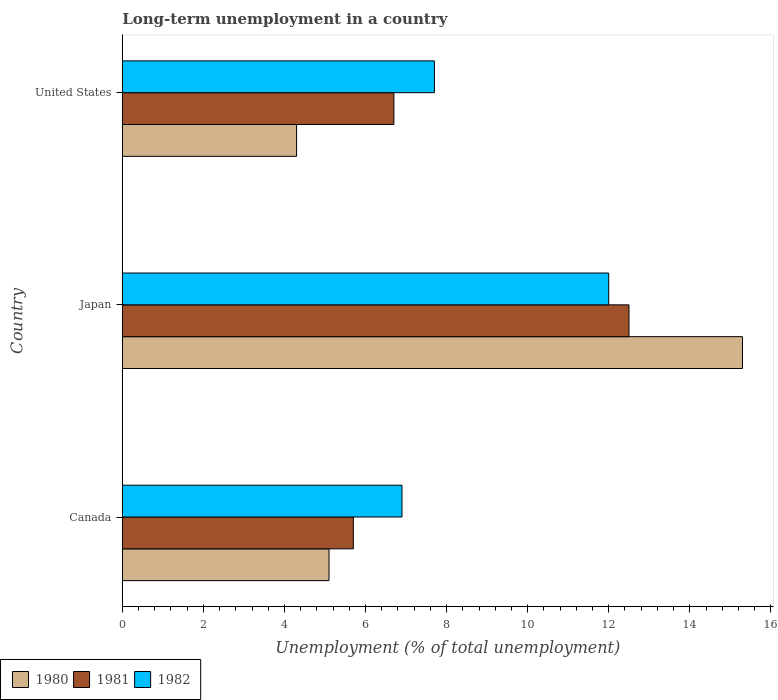How many different coloured bars are there?
Provide a succinct answer. 3. How many groups of bars are there?
Offer a terse response. 3. Are the number of bars per tick equal to the number of legend labels?
Your answer should be compact. Yes. How many bars are there on the 3rd tick from the top?
Your response must be concise. 3. What is the label of the 2nd group of bars from the top?
Your response must be concise. Japan. In how many cases, is the number of bars for a given country not equal to the number of legend labels?
Your answer should be very brief. 0. What is the percentage of long-term unemployed population in 1980 in Japan?
Give a very brief answer. 15.3. Across all countries, what is the maximum percentage of long-term unemployed population in 1982?
Your response must be concise. 12. Across all countries, what is the minimum percentage of long-term unemployed population in 1982?
Offer a very short reply. 6.9. In which country was the percentage of long-term unemployed population in 1981 maximum?
Your response must be concise. Japan. What is the total percentage of long-term unemployed population in 1982 in the graph?
Make the answer very short. 26.6. What is the difference between the percentage of long-term unemployed population in 1980 in Japan and that in United States?
Offer a terse response. 11. What is the difference between the percentage of long-term unemployed population in 1980 in Canada and the percentage of long-term unemployed population in 1982 in United States?
Provide a short and direct response. -2.6. What is the average percentage of long-term unemployed population in 1982 per country?
Give a very brief answer. 8.87. What is the difference between the percentage of long-term unemployed population in 1980 and percentage of long-term unemployed population in 1982 in Canada?
Provide a short and direct response. -1.8. What is the ratio of the percentage of long-term unemployed population in 1981 in Japan to that in United States?
Offer a terse response. 1.87. Is the difference between the percentage of long-term unemployed population in 1980 in Japan and United States greater than the difference between the percentage of long-term unemployed population in 1982 in Japan and United States?
Provide a short and direct response. Yes. What is the difference between the highest and the second highest percentage of long-term unemployed population in 1981?
Your answer should be compact. 5.8. What is the difference between the highest and the lowest percentage of long-term unemployed population in 1982?
Make the answer very short. 5.1. In how many countries, is the percentage of long-term unemployed population in 1982 greater than the average percentage of long-term unemployed population in 1982 taken over all countries?
Offer a terse response. 1. Is the sum of the percentage of long-term unemployed population in 1980 in Japan and United States greater than the maximum percentage of long-term unemployed population in 1982 across all countries?
Keep it short and to the point. Yes. What does the 2nd bar from the top in United States represents?
Keep it short and to the point. 1981. Is it the case that in every country, the sum of the percentage of long-term unemployed population in 1981 and percentage of long-term unemployed population in 1980 is greater than the percentage of long-term unemployed population in 1982?
Keep it short and to the point. Yes. How many bars are there?
Offer a very short reply. 9. What is the difference between two consecutive major ticks on the X-axis?
Provide a short and direct response. 2. Are the values on the major ticks of X-axis written in scientific E-notation?
Ensure brevity in your answer.  No. Does the graph contain any zero values?
Ensure brevity in your answer.  No. Does the graph contain grids?
Make the answer very short. No. Where does the legend appear in the graph?
Your answer should be very brief. Bottom left. How many legend labels are there?
Your answer should be very brief. 3. What is the title of the graph?
Provide a succinct answer. Long-term unemployment in a country. What is the label or title of the X-axis?
Give a very brief answer. Unemployment (% of total unemployment). What is the label or title of the Y-axis?
Your response must be concise. Country. What is the Unemployment (% of total unemployment) in 1980 in Canada?
Keep it short and to the point. 5.1. What is the Unemployment (% of total unemployment) of 1981 in Canada?
Give a very brief answer. 5.7. What is the Unemployment (% of total unemployment) of 1982 in Canada?
Offer a terse response. 6.9. What is the Unemployment (% of total unemployment) of 1980 in Japan?
Provide a succinct answer. 15.3. What is the Unemployment (% of total unemployment) in 1980 in United States?
Give a very brief answer. 4.3. What is the Unemployment (% of total unemployment) in 1981 in United States?
Provide a short and direct response. 6.7. What is the Unemployment (% of total unemployment) in 1982 in United States?
Your answer should be compact. 7.7. Across all countries, what is the maximum Unemployment (% of total unemployment) in 1980?
Give a very brief answer. 15.3. Across all countries, what is the maximum Unemployment (% of total unemployment) of 1981?
Give a very brief answer. 12.5. Across all countries, what is the maximum Unemployment (% of total unemployment) in 1982?
Offer a very short reply. 12. Across all countries, what is the minimum Unemployment (% of total unemployment) in 1980?
Keep it short and to the point. 4.3. Across all countries, what is the minimum Unemployment (% of total unemployment) in 1981?
Your answer should be compact. 5.7. Across all countries, what is the minimum Unemployment (% of total unemployment) in 1982?
Offer a very short reply. 6.9. What is the total Unemployment (% of total unemployment) in 1980 in the graph?
Keep it short and to the point. 24.7. What is the total Unemployment (% of total unemployment) in 1981 in the graph?
Provide a short and direct response. 24.9. What is the total Unemployment (% of total unemployment) in 1982 in the graph?
Make the answer very short. 26.6. What is the difference between the Unemployment (% of total unemployment) of 1981 in Canada and that in Japan?
Your response must be concise. -6.8. What is the difference between the Unemployment (% of total unemployment) of 1982 in Canada and that in Japan?
Offer a very short reply. -5.1. What is the difference between the Unemployment (% of total unemployment) in 1980 in Canada and that in United States?
Your answer should be compact. 0.8. What is the difference between the Unemployment (% of total unemployment) of 1982 in Canada and that in United States?
Your answer should be compact. -0.8. What is the difference between the Unemployment (% of total unemployment) of 1980 in Japan and that in United States?
Offer a very short reply. 11. What is the difference between the Unemployment (% of total unemployment) in 1981 in Japan and that in United States?
Ensure brevity in your answer.  5.8. What is the difference between the Unemployment (% of total unemployment) in 1982 in Japan and that in United States?
Offer a terse response. 4.3. What is the difference between the Unemployment (% of total unemployment) in 1980 in Canada and the Unemployment (% of total unemployment) in 1981 in Japan?
Your response must be concise. -7.4. What is the difference between the Unemployment (% of total unemployment) in 1981 in Canada and the Unemployment (% of total unemployment) in 1982 in Japan?
Your answer should be compact. -6.3. What is the difference between the Unemployment (% of total unemployment) in 1980 in Canada and the Unemployment (% of total unemployment) in 1981 in United States?
Your response must be concise. -1.6. What is the difference between the Unemployment (% of total unemployment) of 1980 in Japan and the Unemployment (% of total unemployment) of 1981 in United States?
Ensure brevity in your answer.  8.6. What is the difference between the Unemployment (% of total unemployment) in 1981 in Japan and the Unemployment (% of total unemployment) in 1982 in United States?
Offer a very short reply. 4.8. What is the average Unemployment (% of total unemployment) of 1980 per country?
Keep it short and to the point. 8.23. What is the average Unemployment (% of total unemployment) in 1982 per country?
Provide a succinct answer. 8.87. What is the difference between the Unemployment (% of total unemployment) of 1980 and Unemployment (% of total unemployment) of 1982 in Canada?
Your answer should be compact. -1.8. What is the difference between the Unemployment (% of total unemployment) of 1980 and Unemployment (% of total unemployment) of 1982 in Japan?
Give a very brief answer. 3.3. What is the difference between the Unemployment (% of total unemployment) in 1981 and Unemployment (% of total unemployment) in 1982 in Japan?
Keep it short and to the point. 0.5. What is the difference between the Unemployment (% of total unemployment) in 1981 and Unemployment (% of total unemployment) in 1982 in United States?
Your answer should be very brief. -1. What is the ratio of the Unemployment (% of total unemployment) in 1980 in Canada to that in Japan?
Offer a very short reply. 0.33. What is the ratio of the Unemployment (% of total unemployment) in 1981 in Canada to that in Japan?
Provide a succinct answer. 0.46. What is the ratio of the Unemployment (% of total unemployment) in 1982 in Canada to that in Japan?
Your answer should be compact. 0.57. What is the ratio of the Unemployment (% of total unemployment) in 1980 in Canada to that in United States?
Your answer should be compact. 1.19. What is the ratio of the Unemployment (% of total unemployment) of 1981 in Canada to that in United States?
Keep it short and to the point. 0.85. What is the ratio of the Unemployment (% of total unemployment) of 1982 in Canada to that in United States?
Make the answer very short. 0.9. What is the ratio of the Unemployment (% of total unemployment) of 1980 in Japan to that in United States?
Offer a terse response. 3.56. What is the ratio of the Unemployment (% of total unemployment) in 1981 in Japan to that in United States?
Ensure brevity in your answer.  1.87. What is the ratio of the Unemployment (% of total unemployment) of 1982 in Japan to that in United States?
Provide a short and direct response. 1.56. What is the difference between the highest and the second highest Unemployment (% of total unemployment) in 1980?
Keep it short and to the point. 10.2. What is the difference between the highest and the second highest Unemployment (% of total unemployment) of 1981?
Offer a very short reply. 5.8. What is the difference between the highest and the lowest Unemployment (% of total unemployment) in 1981?
Make the answer very short. 6.8. 